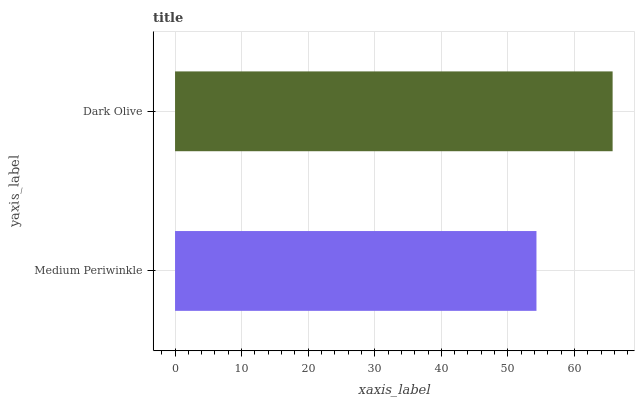Is Medium Periwinkle the minimum?
Answer yes or no. Yes. Is Dark Olive the maximum?
Answer yes or no. Yes. Is Dark Olive the minimum?
Answer yes or no. No. Is Dark Olive greater than Medium Periwinkle?
Answer yes or no. Yes. Is Medium Periwinkle less than Dark Olive?
Answer yes or no. Yes. Is Medium Periwinkle greater than Dark Olive?
Answer yes or no. No. Is Dark Olive less than Medium Periwinkle?
Answer yes or no. No. Is Dark Olive the high median?
Answer yes or no. Yes. Is Medium Periwinkle the low median?
Answer yes or no. Yes. Is Medium Periwinkle the high median?
Answer yes or no. No. Is Dark Olive the low median?
Answer yes or no. No. 